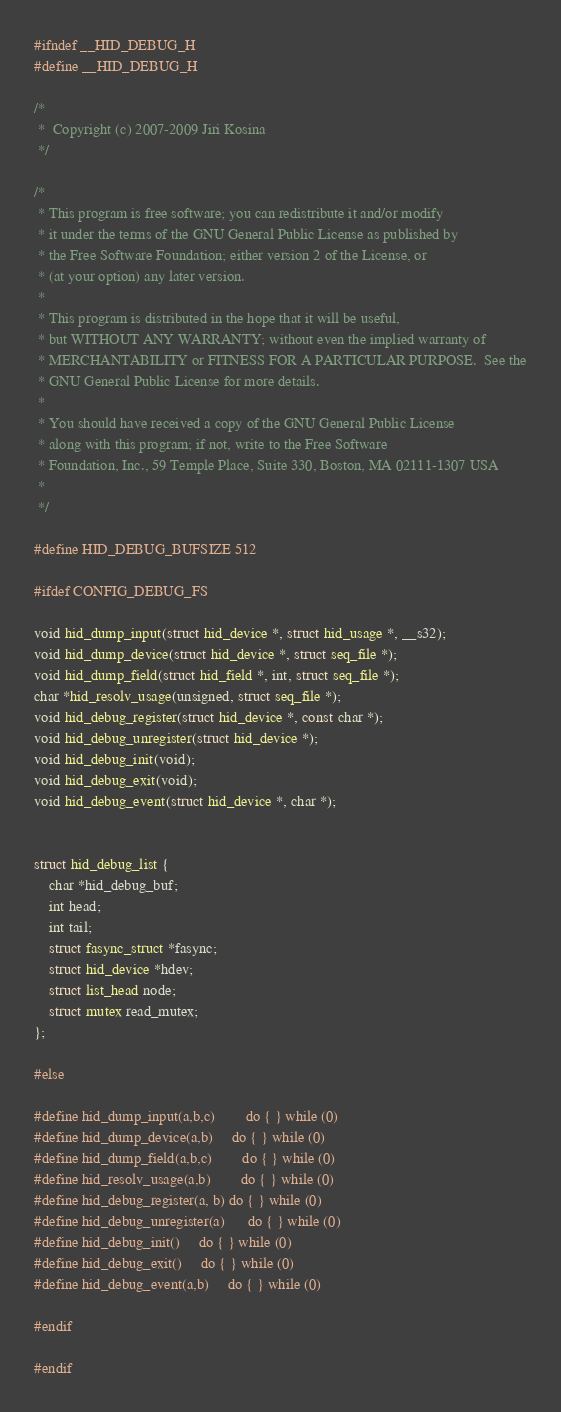Convert code to text. <code><loc_0><loc_0><loc_500><loc_500><_C_>#ifndef __HID_DEBUG_H
#define __HID_DEBUG_H

/*
 *  Copyright (c) 2007-2009	Jiri Kosina
 */

/*
 * This program is free software; you can redistribute it and/or modify
 * it under the terms of the GNU General Public License as published by
 * the Free Software Foundation; either version 2 of the License, or
 * (at your option) any later version.
 *
 * This program is distributed in the hope that it will be useful,
 * but WITHOUT ANY WARRANTY; without even the implied warranty of
 * MERCHANTABILITY or FITNESS FOR A PARTICULAR PURPOSE.  See the
 * GNU General Public License for more details.
 *
 * You should have received a copy of the GNU General Public License
 * along with this program; if not, write to the Free Software
 * Foundation, Inc., 59 Temple Place, Suite 330, Boston, MA 02111-1307 USA
 *
 */

#define HID_DEBUG_BUFSIZE 512

#ifdef CONFIG_DEBUG_FS

void hid_dump_input(struct hid_device *, struct hid_usage *, __s32);
void hid_dump_device(struct hid_device *, struct seq_file *);
void hid_dump_field(struct hid_field *, int, struct seq_file *);
char *hid_resolv_usage(unsigned, struct seq_file *);
void hid_debug_register(struct hid_device *, const char *);
void hid_debug_unregister(struct hid_device *);
void hid_debug_init(void);
void hid_debug_exit(void);
void hid_debug_event(struct hid_device *, char *);


struct hid_debug_list {
	char *hid_debug_buf;
	int head;
	int tail;
	struct fasync_struct *fasync;
	struct hid_device *hdev;
	struct list_head node;
	struct mutex read_mutex;
};

#else

#define hid_dump_input(a,b,c)		do { } while (0)
#define hid_dump_device(a,b)		do { } while (0)
#define hid_dump_field(a,b,c)		do { } while (0)
#define hid_resolv_usage(a,b)		do { } while (0)
#define hid_debug_register(a, b)	do { } while (0)
#define hid_debug_unregister(a)		do { } while (0)
#define hid_debug_init()		do { } while (0)
#define hid_debug_exit()		do { } while (0)
#define hid_debug_event(a,b)		do { } while (0)

#endif

#endif
</code> 